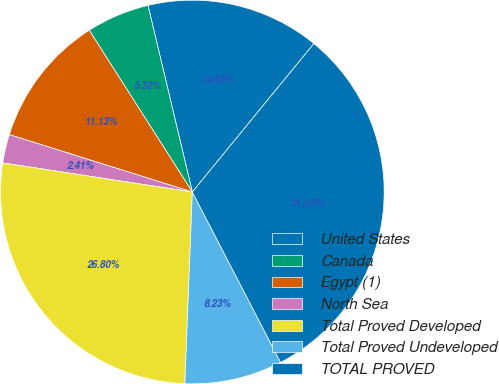Convert chart to OTSL. <chart><loc_0><loc_0><loc_500><loc_500><pie_chart><fcel>United States<fcel>Canada<fcel>Egypt (1)<fcel>North Sea<fcel>Total Proved Developed<fcel>Total Proved Undeveloped<fcel>TOTAL PROVED<nl><fcel>14.63%<fcel>5.32%<fcel>11.13%<fcel>2.41%<fcel>26.8%<fcel>8.23%<fcel>31.47%<nl></chart> 